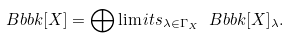Convert formula to latex. <formula><loc_0><loc_0><loc_500><loc_500>\ B b b k [ X ] = \bigoplus \lim i t s _ { \lambda \in \Gamma _ { X } } \ B b b k [ X ] _ { \lambda } .</formula> 